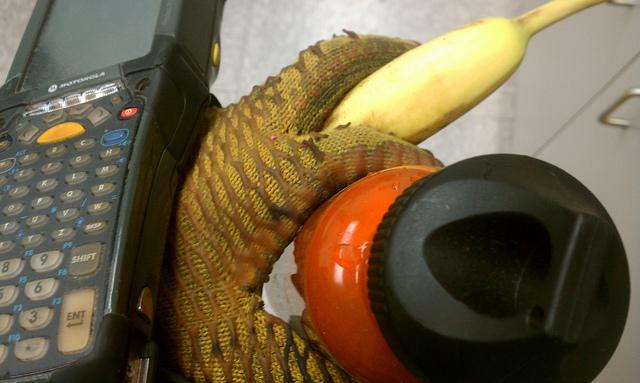Is the banana ripe?
Write a very short answer. Yes. What is the banana laying on?
Keep it brief. Table. Is there a banana in this picture?
Concise answer only. Yes. What is holding the banana?
Give a very brief answer. Banana holder. Do you see something that holds fluids?
Be succinct. Yes. What is visible at the right edge of the image?
Be succinct. Water bottle. 